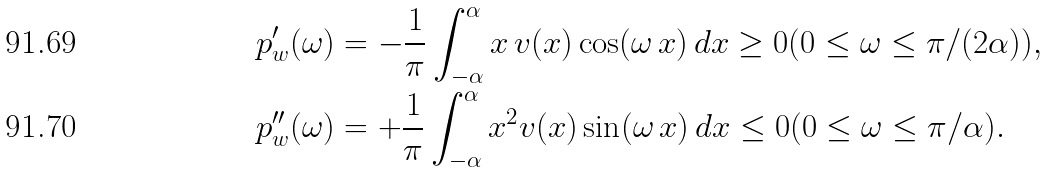<formula> <loc_0><loc_0><loc_500><loc_500>p _ { w } ^ { \prime } ( \omega ) & = - \frac { 1 } { \pi } \int _ { - \alpha } ^ { \alpha } x \, v ( x ) \cos ( \omega \, x ) \, d x \geq 0 ( 0 \leq \omega \leq \pi / ( 2 \alpha ) ) , \\ p _ { w } ^ { \prime \prime } ( \omega ) & = + \frac { 1 } { \pi } \int _ { - \alpha } ^ { \alpha } x ^ { 2 } v ( x ) \sin ( \omega \, x ) \, d x \leq 0 ( 0 \leq \omega \leq \pi / \alpha ) .</formula> 